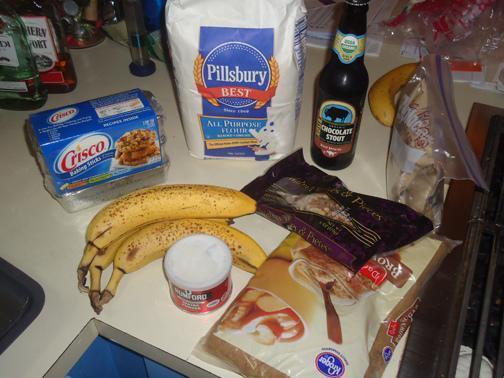How many bananas are visible?
Give a very brief answer. 3. How many bottles are visible?
Give a very brief answer. 3. How many men are drinking milk?
Give a very brief answer. 0. 